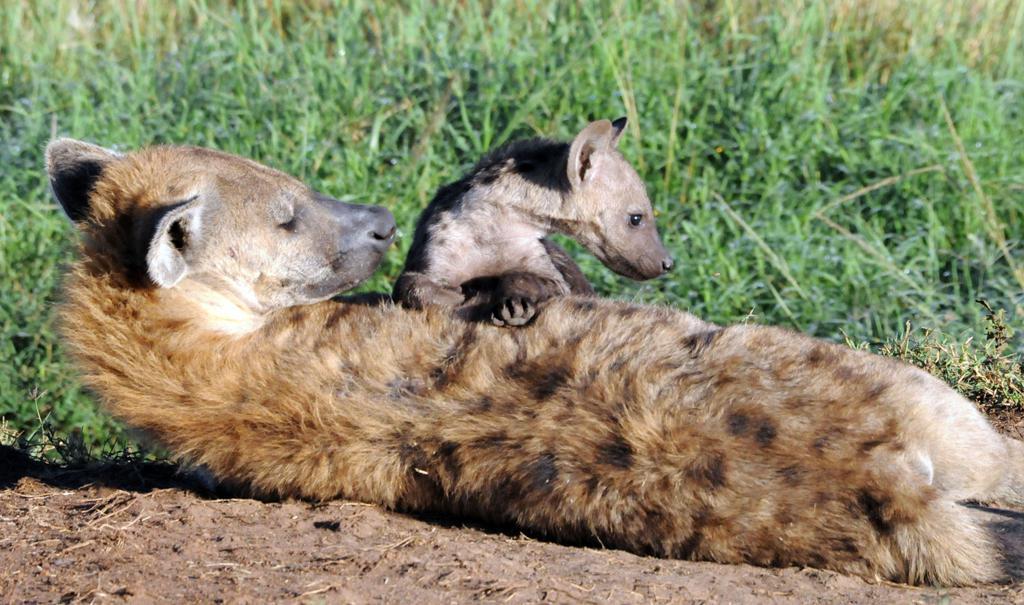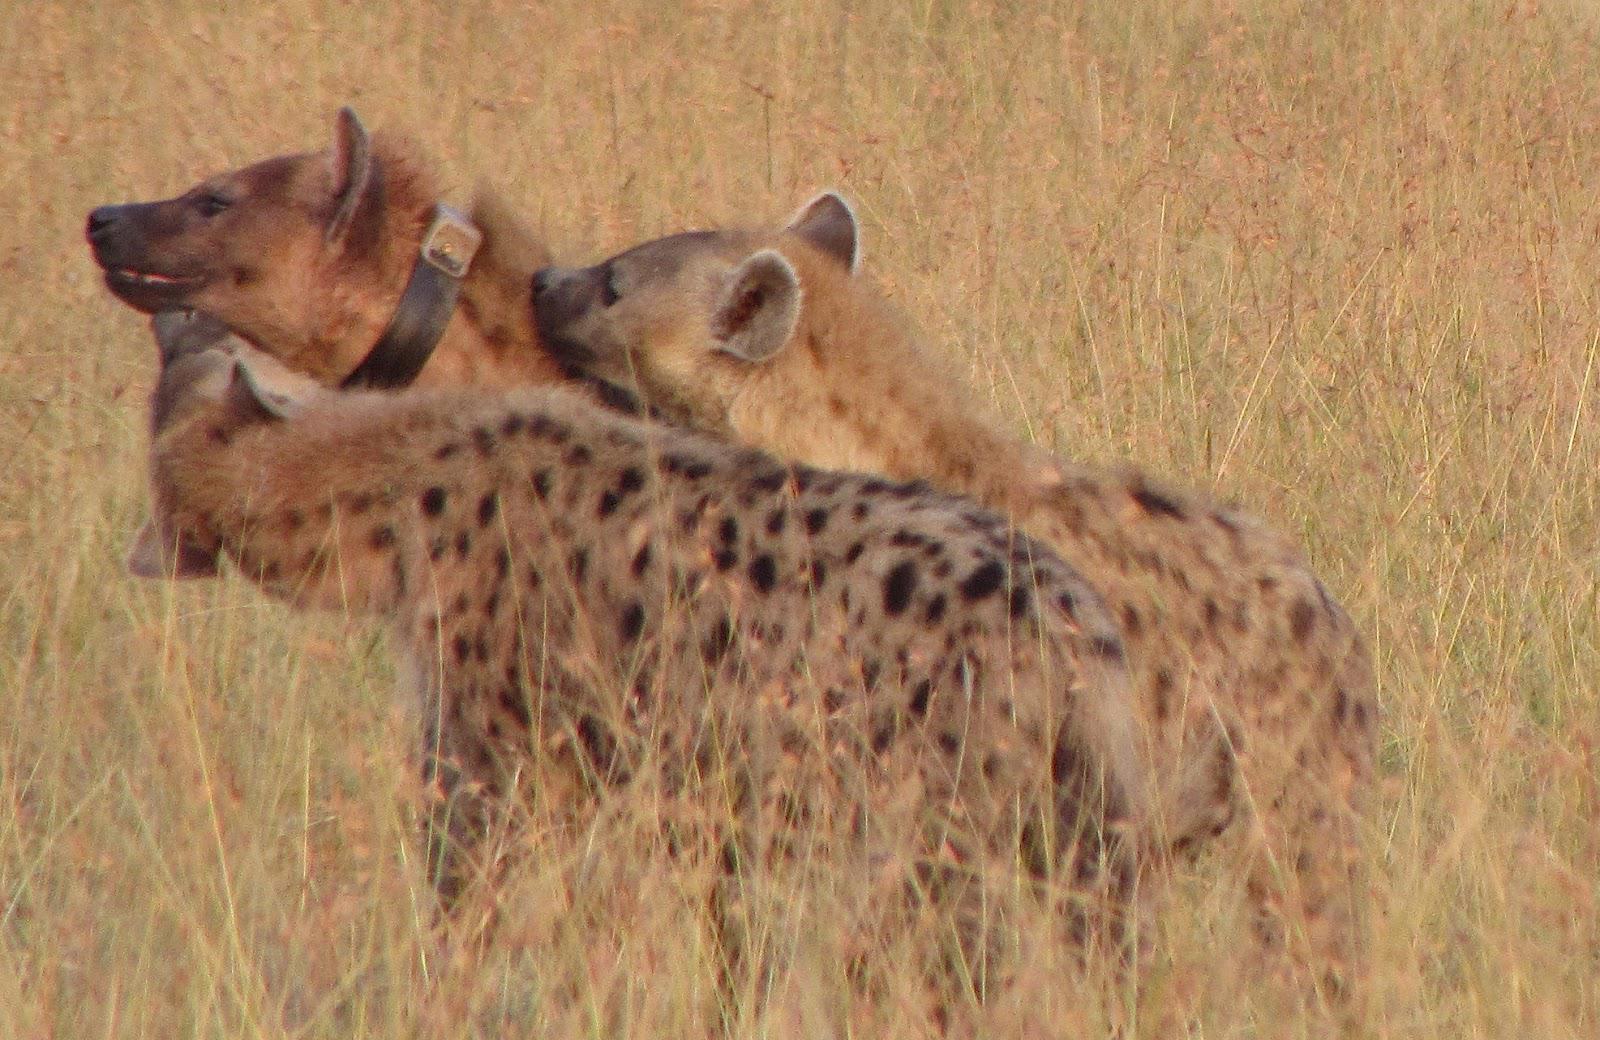The first image is the image on the left, the second image is the image on the right. Given the left and right images, does the statement "One image shows exactly three hyenas standing with bodies turned leftward, some with heads craning to touch one of the others." hold true? Answer yes or no. Yes. The first image is the image on the left, the second image is the image on the right. Given the left and right images, does the statement "there is a hyena on brown grass with its mmouth open exposing the top and bottom teeth from the side view" hold true? Answer yes or no. No. 